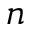<formula> <loc_0><loc_0><loc_500><loc_500>n</formula> 